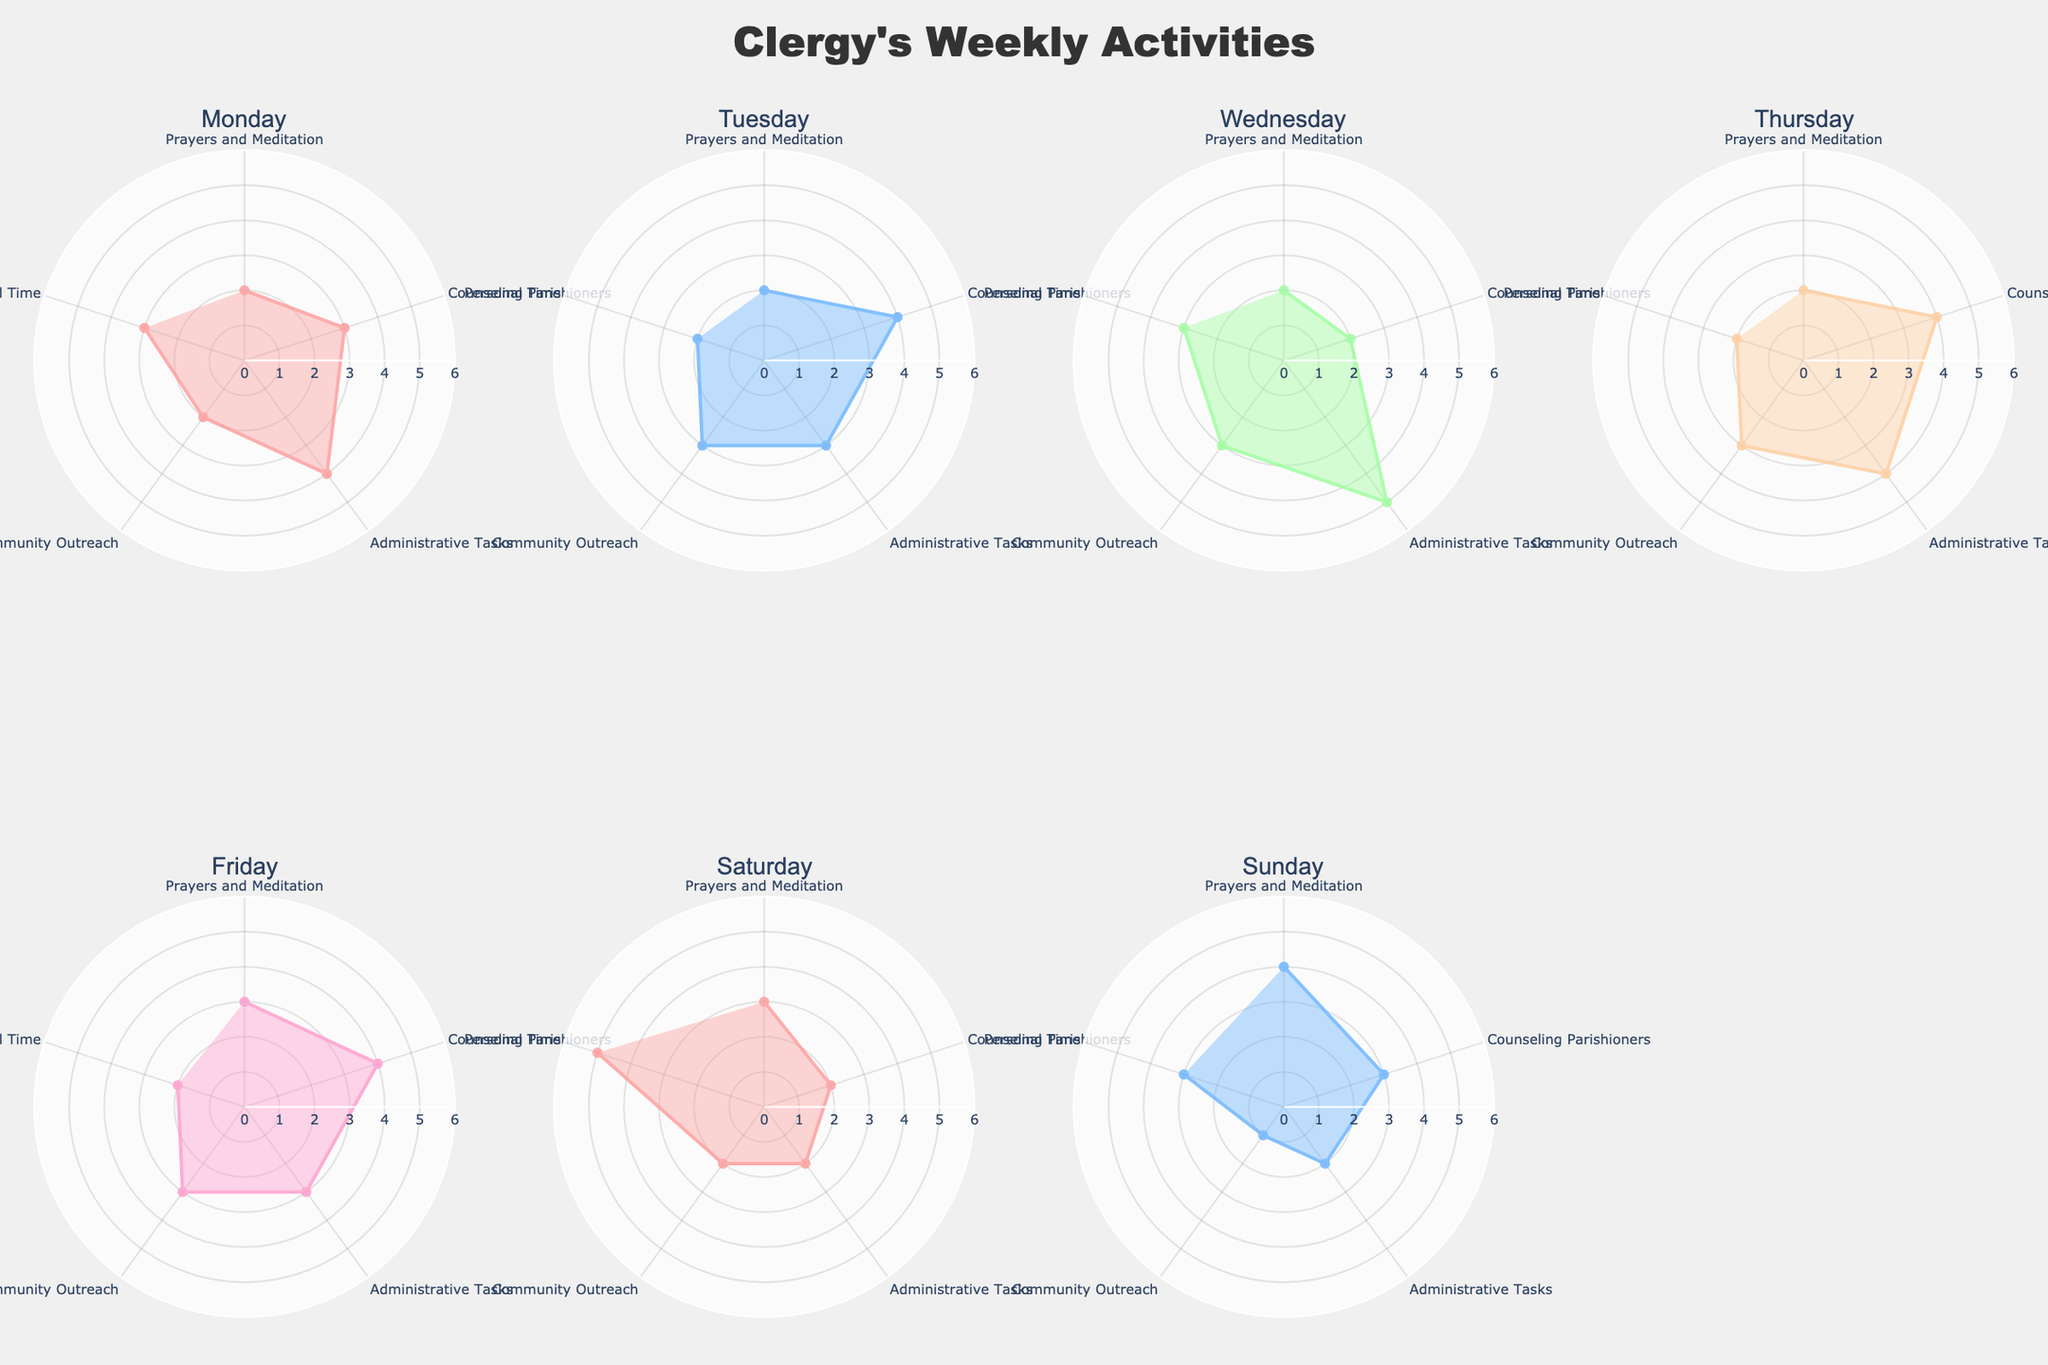How many hours did the clergy member spend on Community Outreach on Tuesday? Look at the subplot for Tuesday and check the radial value for the section labeled Community Outreach. The value is 3 hours.
Answer: 3 Which day did the clergy member spend the most time in Prayers and Meditation? Compare the radial values for Prayers and Meditation across all subplots. Sunday has the highest value at 4 hours.
Answer: Sunday What is the combined total time spent on Administrative Tasks from Monday to Wednesday? Sum the radial values for Administrative Tasks on Monday (4 hours), Tuesday (3 hours), and Wednesday (5 hours): 4 + 3 + 5 = 12 hours.
Answer: 12 On which day did the clergy member spend equal hours on Counseling Parishioners and Prayers and Meditation? Look at the radial values for Counseling Parishioners and Prayers and Meditation across all subplots. On Saturday, both have 2 hours each.
Answer: Saturday How does the time spent on Personal Time vary across the week? Compare the radial values for Personal Time in each subplot. The time varies: Monday (3 hours), Tuesday (2 hours), Wednesday (3 hours), Thursday (2 hours), Friday (2 hours), Saturday (5 hours), Sunday (3 hours).
Answer: varies Which day has the most balanced distribution in hours among all activities (minimal difference between categories)? Compare the differences in radial values for each subplot. Saturday seems most balanced with values close to each other: Prayers and Meditation (3), Counseling Parishioners (2), Administrative Tasks (2), Community Outreach (2), Personal Time (5).
Answer: Saturday What is the most common number of hours spent on Counseling Parishioners? Check the radial values for Counseling Parishioners across all subplots. The most frequent value is 4 hours.
Answer: 4 Is there a day where the total hours spent on all activities is the highest? Sum the radial values for each day. For instance, for Friday: Prayers and Meditation (3), Counseling Parishioners (4), Administrative Tasks (3), Community Outreach (3), Personal Time (2) give 15 hours. Do this for all days and Friday comes out the highest at 15 hours.
Answer: Friday 